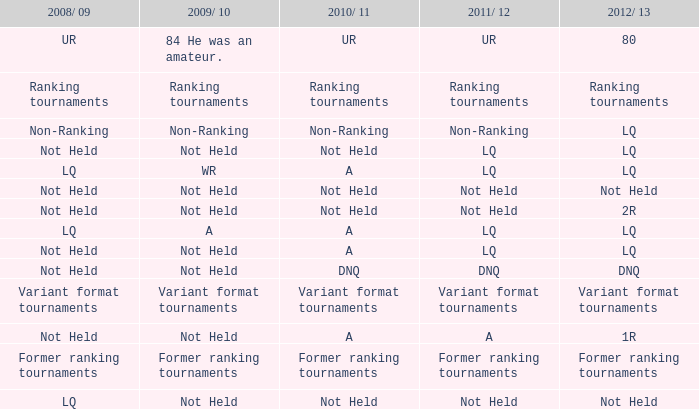What is the 2009/10 situation when the 2011/12 is considered non-ranking? Non-Ranking. 